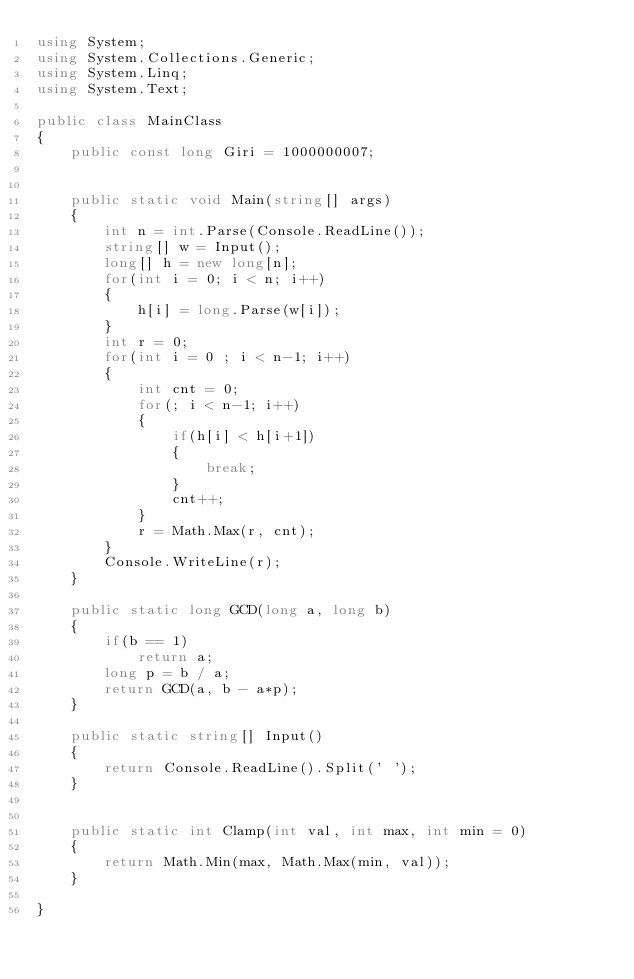<code> <loc_0><loc_0><loc_500><loc_500><_C#_>using System;
using System.Collections.Generic;
using System.Linq;
using System.Text;

public class MainClass
{
	public const long Giri = 1000000007;

	
	public static void Main(string[] args)
	{
		int n = int.Parse(Console.ReadLine());
		string[] w = Input();
		long[] h = new long[n];
		for(int i = 0; i < n; i++)
		{
			h[i] = long.Parse(w[i]);
		}
		int r = 0;
		for(int i = 0 ; i < n-1; i++)
		{
			int cnt = 0;
			for(; i < n-1; i++)
			{
				if(h[i] < h[i+1])
				{
					break;
				}
				cnt++;
			}
			r = Math.Max(r, cnt);
		}
		Console.WriteLine(r);
	}
	
	public static long GCD(long a, long b)
	{
		if(b == 1)
			return a;
		long p = b / a;
		return GCD(a, b - a*p);
	}
	
	public static string[] Input()
	{
		return Console.ReadLine().Split(' ');
	}

	
	public static int Clamp(int val, int max, int min = 0)
	{
		return Math.Min(max, Math.Max(min, val));
	}

}

</code> 